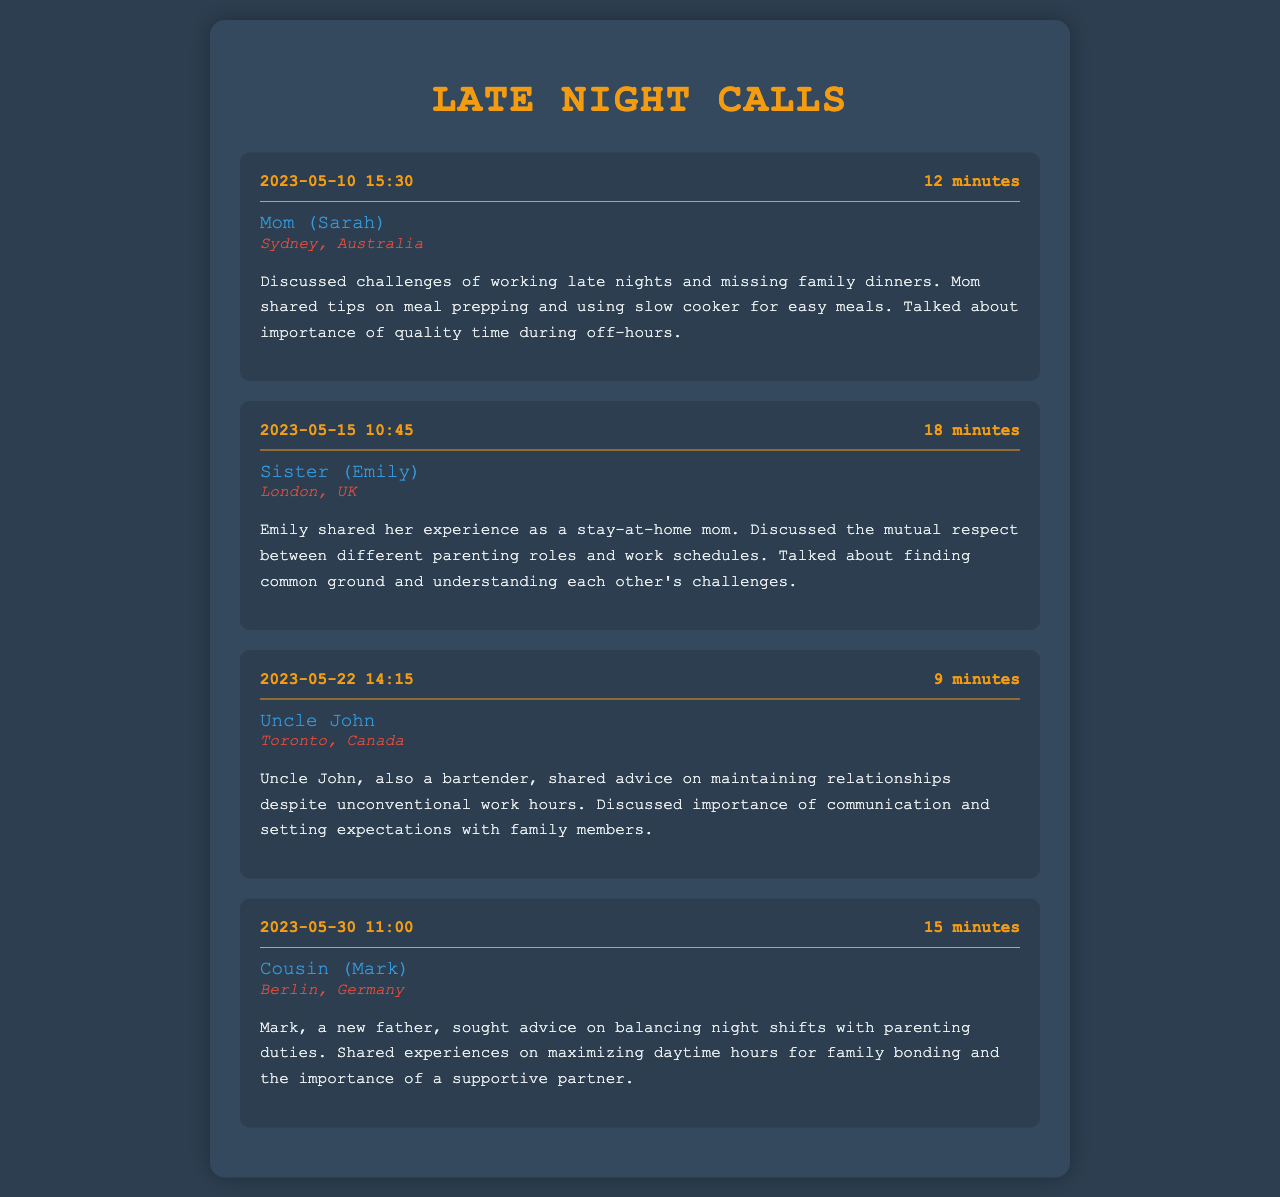What is the date of the call with Mom? The call with Mom occurred on May 10, 2023, as indicated in the call log.
Answer: May 10, 2023 How long was the call with Uncle John? The duration of the call with Uncle John is listed as 9 minutes.
Answer: 9 minutes Where does Sister Emily live? Emily's location is specified as London, UK in the call log.
Answer: London, UK What parenting topic did Mark discuss with the bartender? Mark sought advice on balancing night shifts with parenting duties during his call.
Answer: Balancing night shifts How did Mom suggest managing meals? Mom shared tips on meal prepping and using a slow cooker during the conversation.
Answer: Meal prepping and slow cooker What is a common challenge mentioned by the family members? The family discussed the challenge of maintaining quality time while working unconventional hours.
Answer: Maintaining quality time Which family member is also a bartender? Uncle John is identified as a bartender, sharing advice in the call log.
Answer: Uncle John What was the duration of the call with Cousin Mark? The call with Cousin Mark lasted 15 minutes, according to the call log.
Answer: 15 minutes 